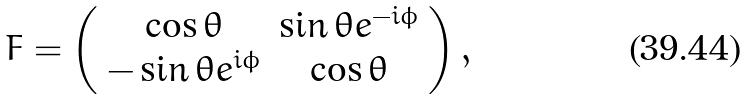<formula> <loc_0><loc_0><loc_500><loc_500>F = \left ( \begin{array} { c c } \cos \theta & \sin \theta e ^ { - i \phi } \\ - \sin \theta e ^ { i \phi } & \cos \theta \\ \end{array} \right ) ,</formula> 